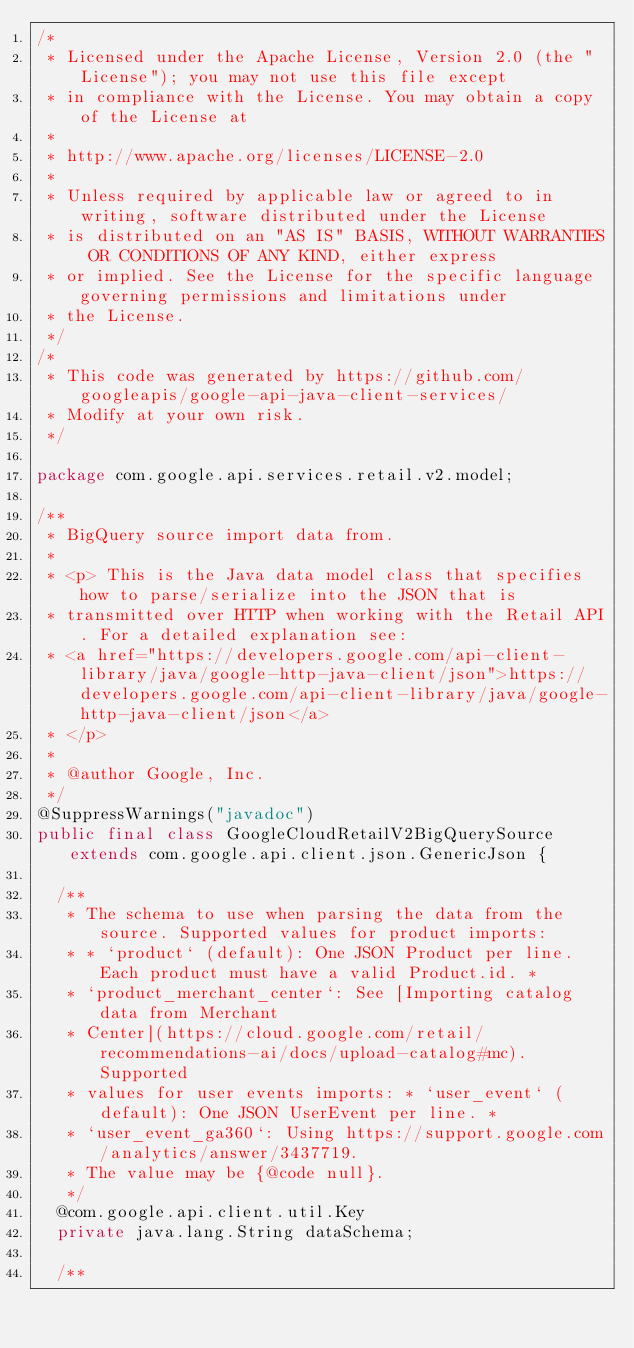<code> <loc_0><loc_0><loc_500><loc_500><_Java_>/*
 * Licensed under the Apache License, Version 2.0 (the "License"); you may not use this file except
 * in compliance with the License. You may obtain a copy of the License at
 *
 * http://www.apache.org/licenses/LICENSE-2.0
 *
 * Unless required by applicable law or agreed to in writing, software distributed under the License
 * is distributed on an "AS IS" BASIS, WITHOUT WARRANTIES OR CONDITIONS OF ANY KIND, either express
 * or implied. See the License for the specific language governing permissions and limitations under
 * the License.
 */
/*
 * This code was generated by https://github.com/googleapis/google-api-java-client-services/
 * Modify at your own risk.
 */

package com.google.api.services.retail.v2.model;

/**
 * BigQuery source import data from.
 *
 * <p> This is the Java data model class that specifies how to parse/serialize into the JSON that is
 * transmitted over HTTP when working with the Retail API. For a detailed explanation see:
 * <a href="https://developers.google.com/api-client-library/java/google-http-java-client/json">https://developers.google.com/api-client-library/java/google-http-java-client/json</a>
 * </p>
 *
 * @author Google, Inc.
 */
@SuppressWarnings("javadoc")
public final class GoogleCloudRetailV2BigQuerySource extends com.google.api.client.json.GenericJson {

  /**
   * The schema to use when parsing the data from the source. Supported values for product imports:
   * * `product` (default): One JSON Product per line. Each product must have a valid Product.id. *
   * `product_merchant_center`: See [Importing catalog data from Merchant
   * Center](https://cloud.google.com/retail/recommendations-ai/docs/upload-catalog#mc). Supported
   * values for user events imports: * `user_event` (default): One JSON UserEvent per line. *
   * `user_event_ga360`: Using https://support.google.com/analytics/answer/3437719.
   * The value may be {@code null}.
   */
  @com.google.api.client.util.Key
  private java.lang.String dataSchema;

  /**</code> 